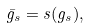<formula> <loc_0><loc_0><loc_500><loc_500>\bar { g } _ { s } = s ( g _ { s } ) ,</formula> 